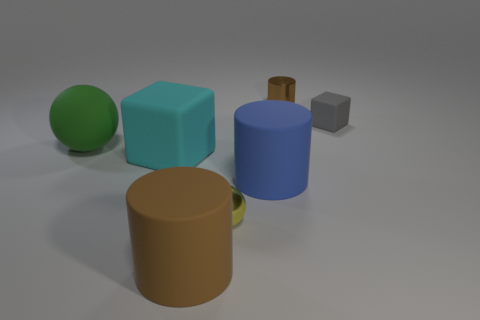Add 1 tiny gray matte cylinders. How many objects exist? 8 Subtract all cylinders. How many objects are left? 4 Add 6 gray blocks. How many gray blocks exist? 7 Subtract 0 red cylinders. How many objects are left? 7 Subtract all brown metal cylinders. Subtract all small cubes. How many objects are left? 5 Add 4 large brown cylinders. How many large brown cylinders are left? 5 